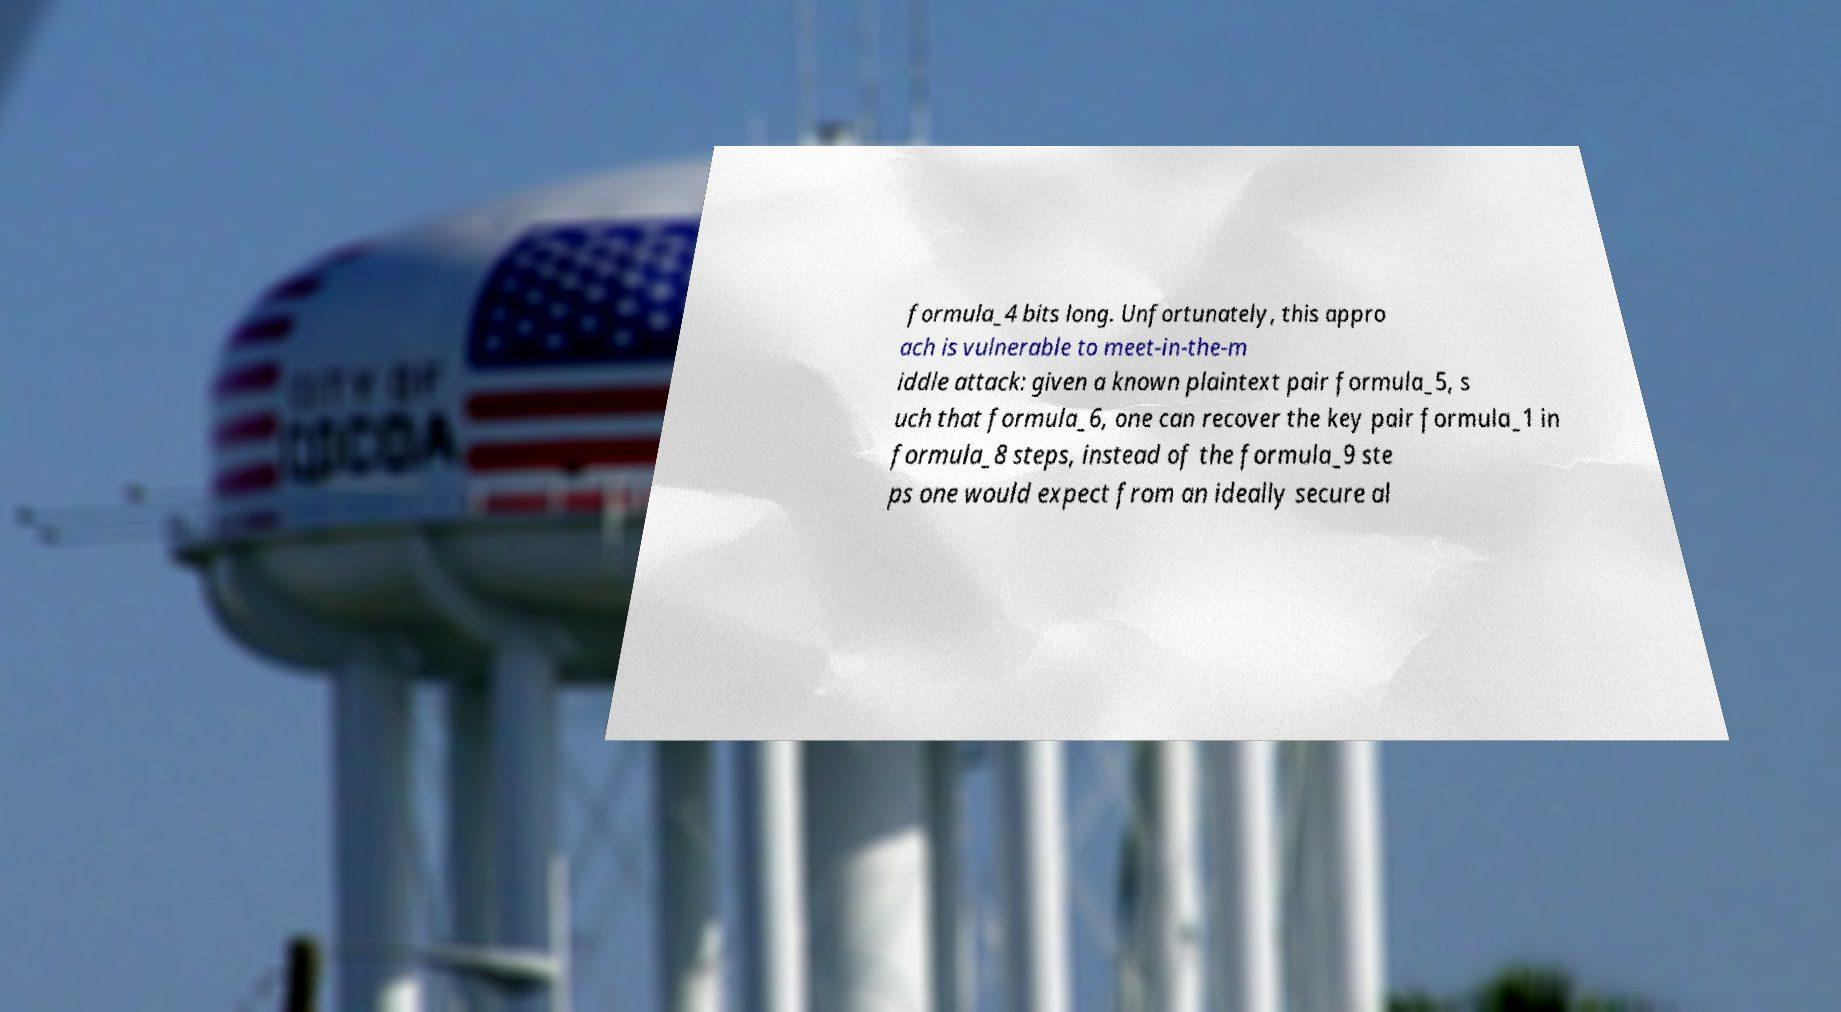Could you assist in decoding the text presented in this image and type it out clearly? formula_4 bits long. Unfortunately, this appro ach is vulnerable to meet-in-the-m iddle attack: given a known plaintext pair formula_5, s uch that formula_6, one can recover the key pair formula_1 in formula_8 steps, instead of the formula_9 ste ps one would expect from an ideally secure al 